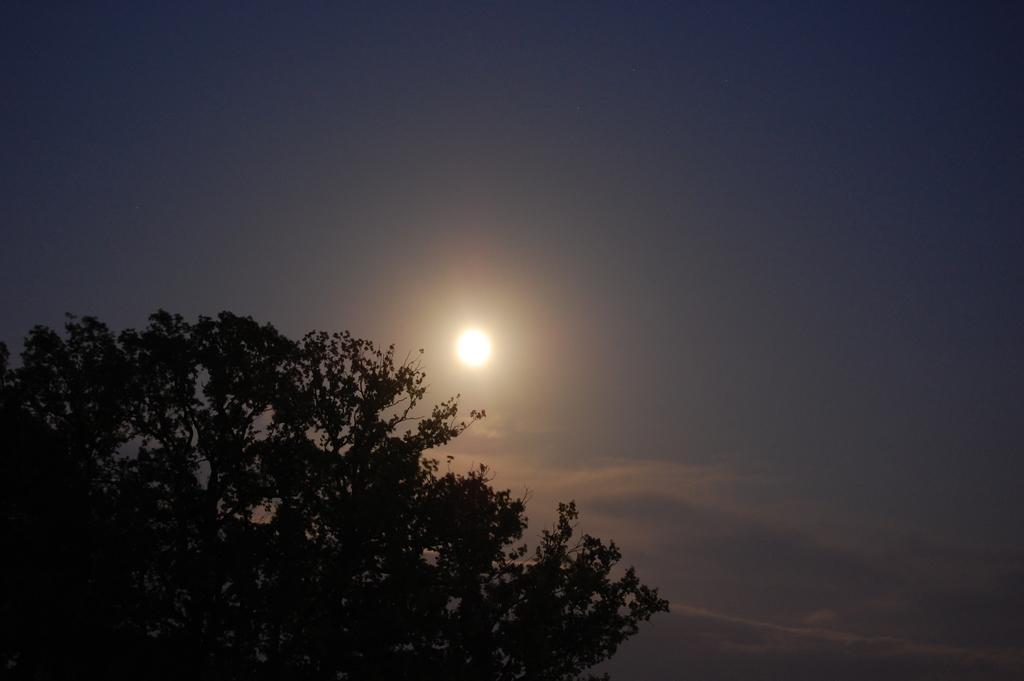Can you describe this image briefly? In this image there is tree and moon in the sky. 